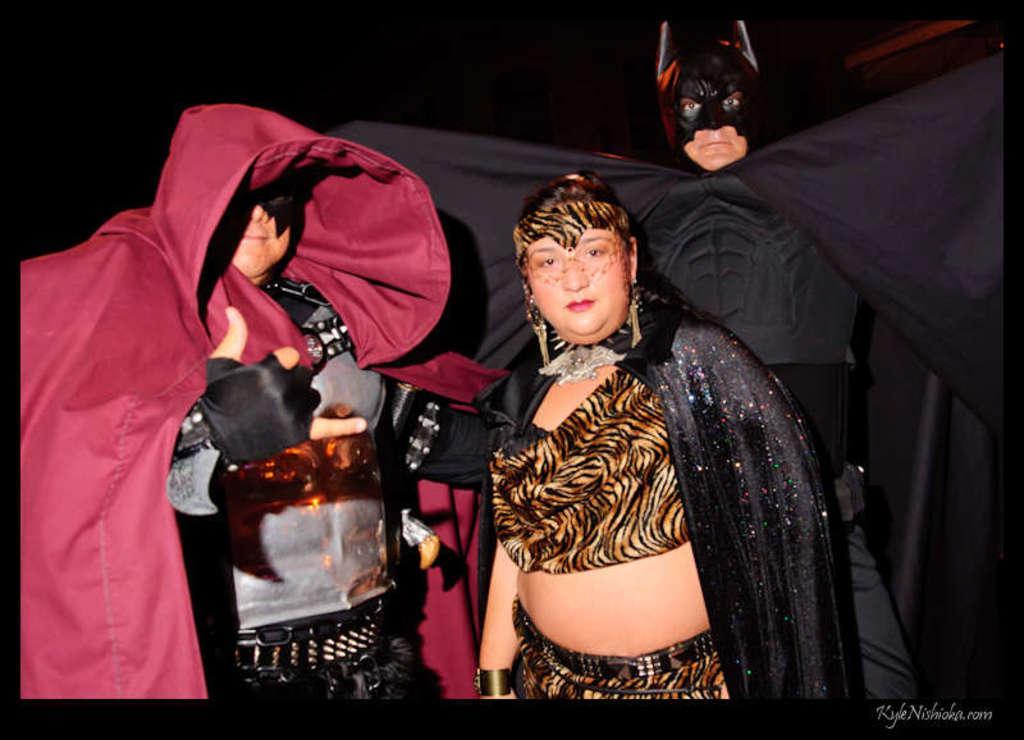Can you describe this image briefly? In the picture I can see a person wearing maroon color dress is standing on the left side of the image and a person wearing a black dress is standing on the right side of the image and we can see another person wearing black color dress is behind her. The background of the image is dark. Here we can see the watermark at the bottom right side of the image. 